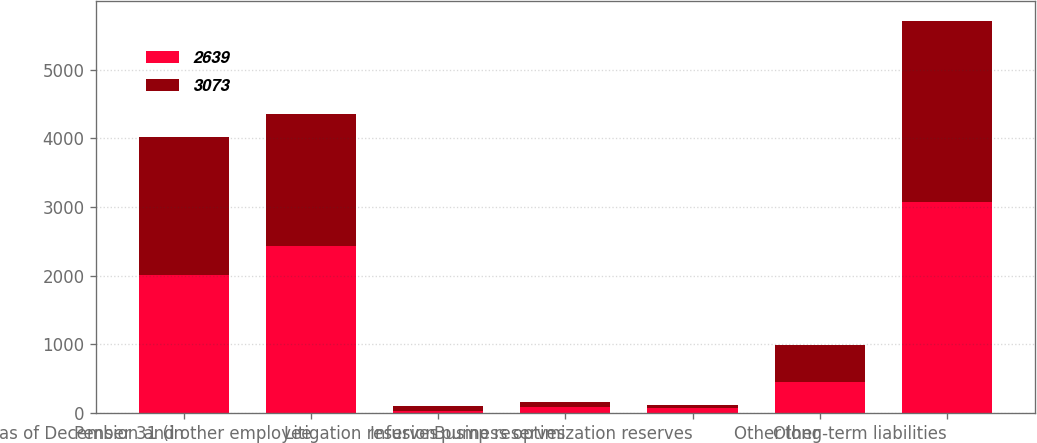<chart> <loc_0><loc_0><loc_500><loc_500><stacked_bar_chart><ecel><fcel>as of December 31 (in<fcel>Pension and other employee<fcel>Litigation reserves<fcel>Infusion pump reserves<fcel>Business optimization reserves<fcel>Other<fcel>Other long-term liabilities<nl><fcel>2639<fcel>2012<fcel>2427<fcel>32<fcel>90<fcel>69<fcel>455<fcel>3073<nl><fcel>3073<fcel>2011<fcel>1920<fcel>63<fcel>74<fcel>49<fcel>533<fcel>2639<nl></chart> 